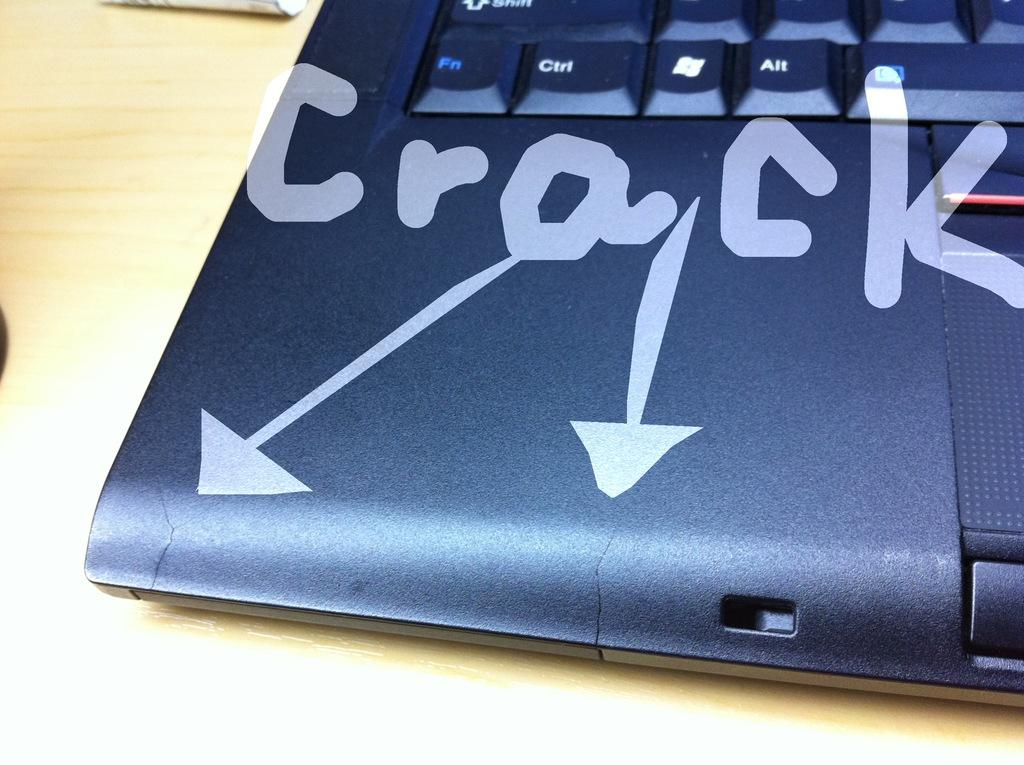<image>
Provide a brief description of the given image. Markings on the corner of a laptop point to where the cracks are. 